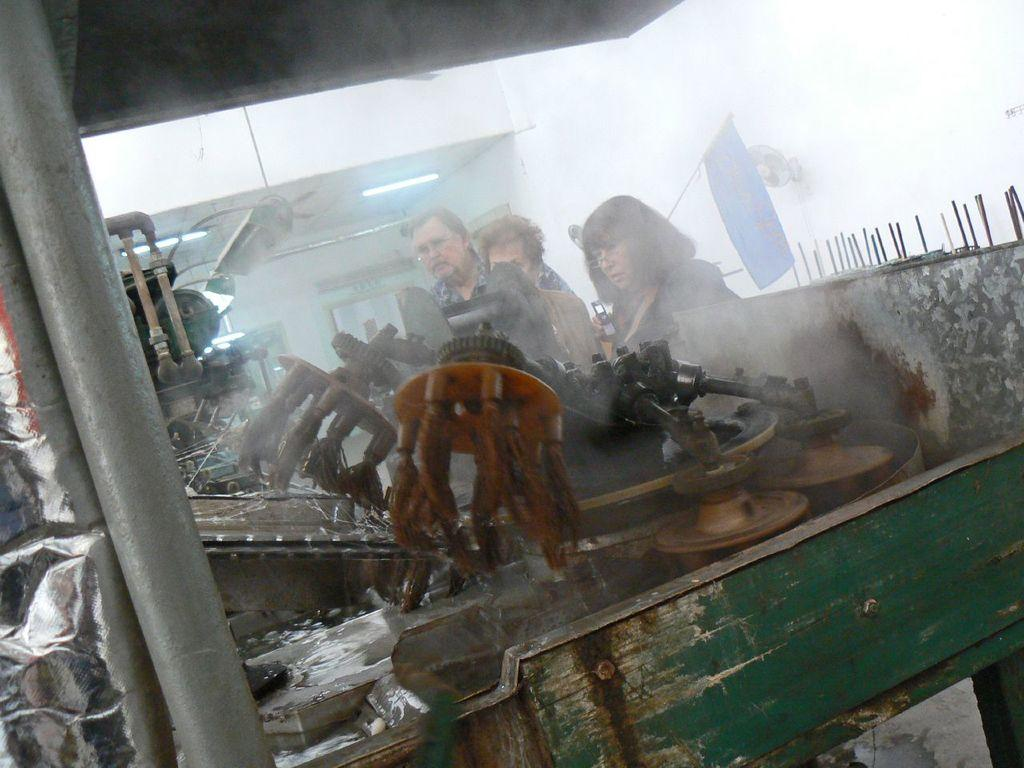How many people are in the image? There are three persons standing in the image. What else can be seen in the image besides the people? There appears to be a machine and lights visible in the image. Can you describe the machine in the image? Unfortunately, the facts provided do not give enough detail to describe the machine. What other objects are present in the image? There are other objects present in the image, but their specific nature is not mentioned in the facts provided. What type of orange is being peeled by one of the persons in the image? There is no orange present in the image, so it cannot be determined if someone is peeling an orange. 